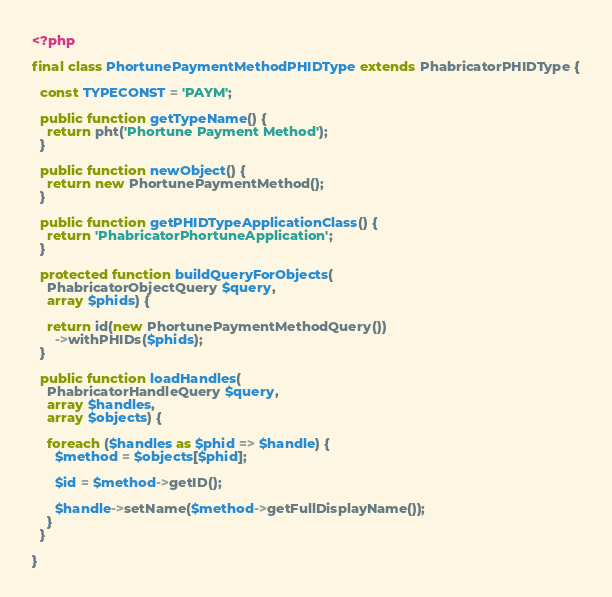Convert code to text. <code><loc_0><loc_0><loc_500><loc_500><_PHP_><?php

final class PhortunePaymentMethodPHIDType extends PhabricatorPHIDType {

  const TYPECONST = 'PAYM';

  public function getTypeName() {
    return pht('Phortune Payment Method');
  }

  public function newObject() {
    return new PhortunePaymentMethod();
  }

  public function getPHIDTypeApplicationClass() {
    return 'PhabricatorPhortuneApplication';
  }

  protected function buildQueryForObjects(
    PhabricatorObjectQuery $query,
    array $phids) {

    return id(new PhortunePaymentMethodQuery())
      ->withPHIDs($phids);
  }

  public function loadHandles(
    PhabricatorHandleQuery $query,
    array $handles,
    array $objects) {

    foreach ($handles as $phid => $handle) {
      $method = $objects[$phid];

      $id = $method->getID();

      $handle->setName($method->getFullDisplayName());
    }
  }

}
</code> 